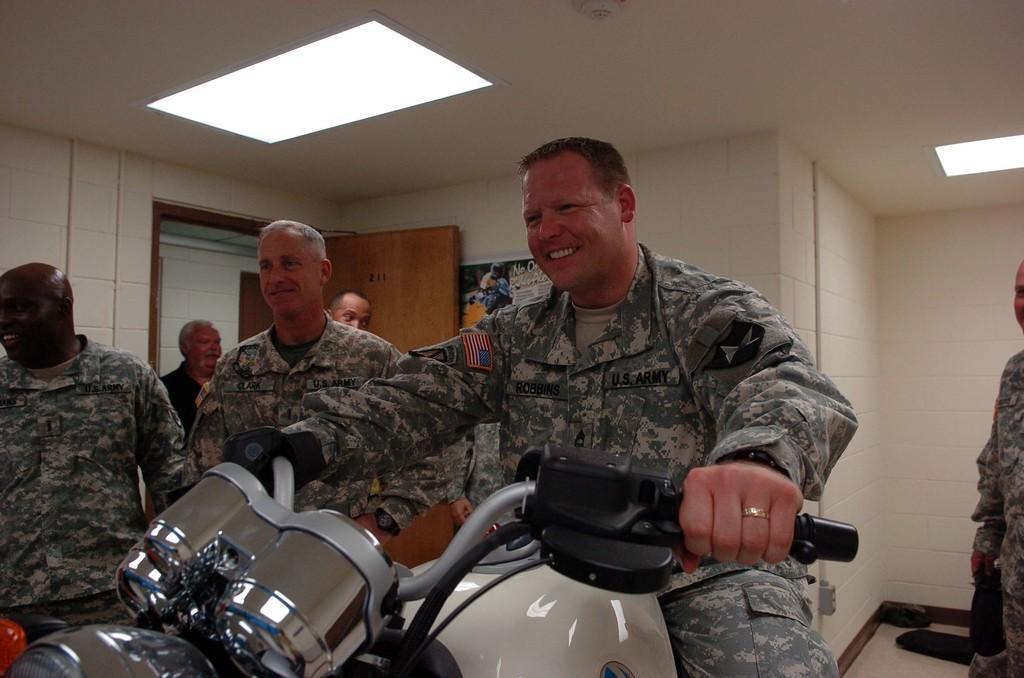Describe this image in one or two sentences. There is a man sitting and holding bike and few persons are standing. On the background we can see poster on wall and door. On top we can see lights. 